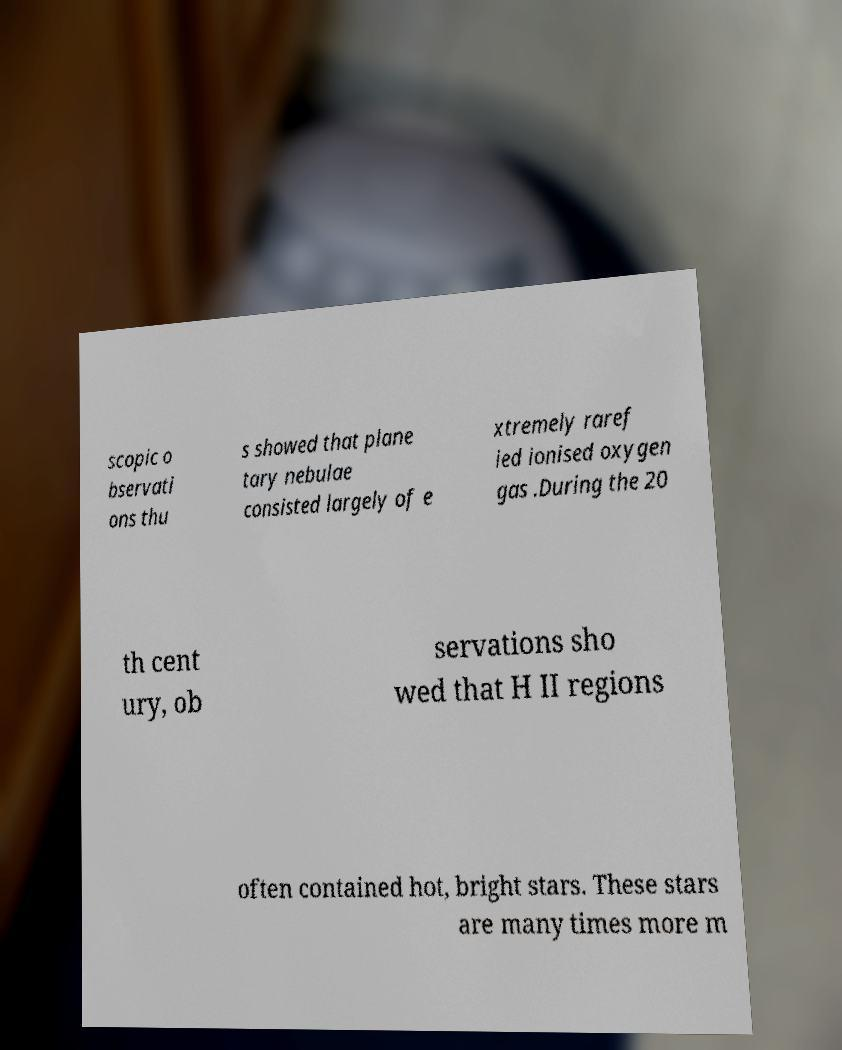Can you accurately transcribe the text from the provided image for me? scopic o bservati ons thu s showed that plane tary nebulae consisted largely of e xtremely raref ied ionised oxygen gas .During the 20 th cent ury, ob servations sho wed that H II regions often contained hot, bright stars. These stars are many times more m 